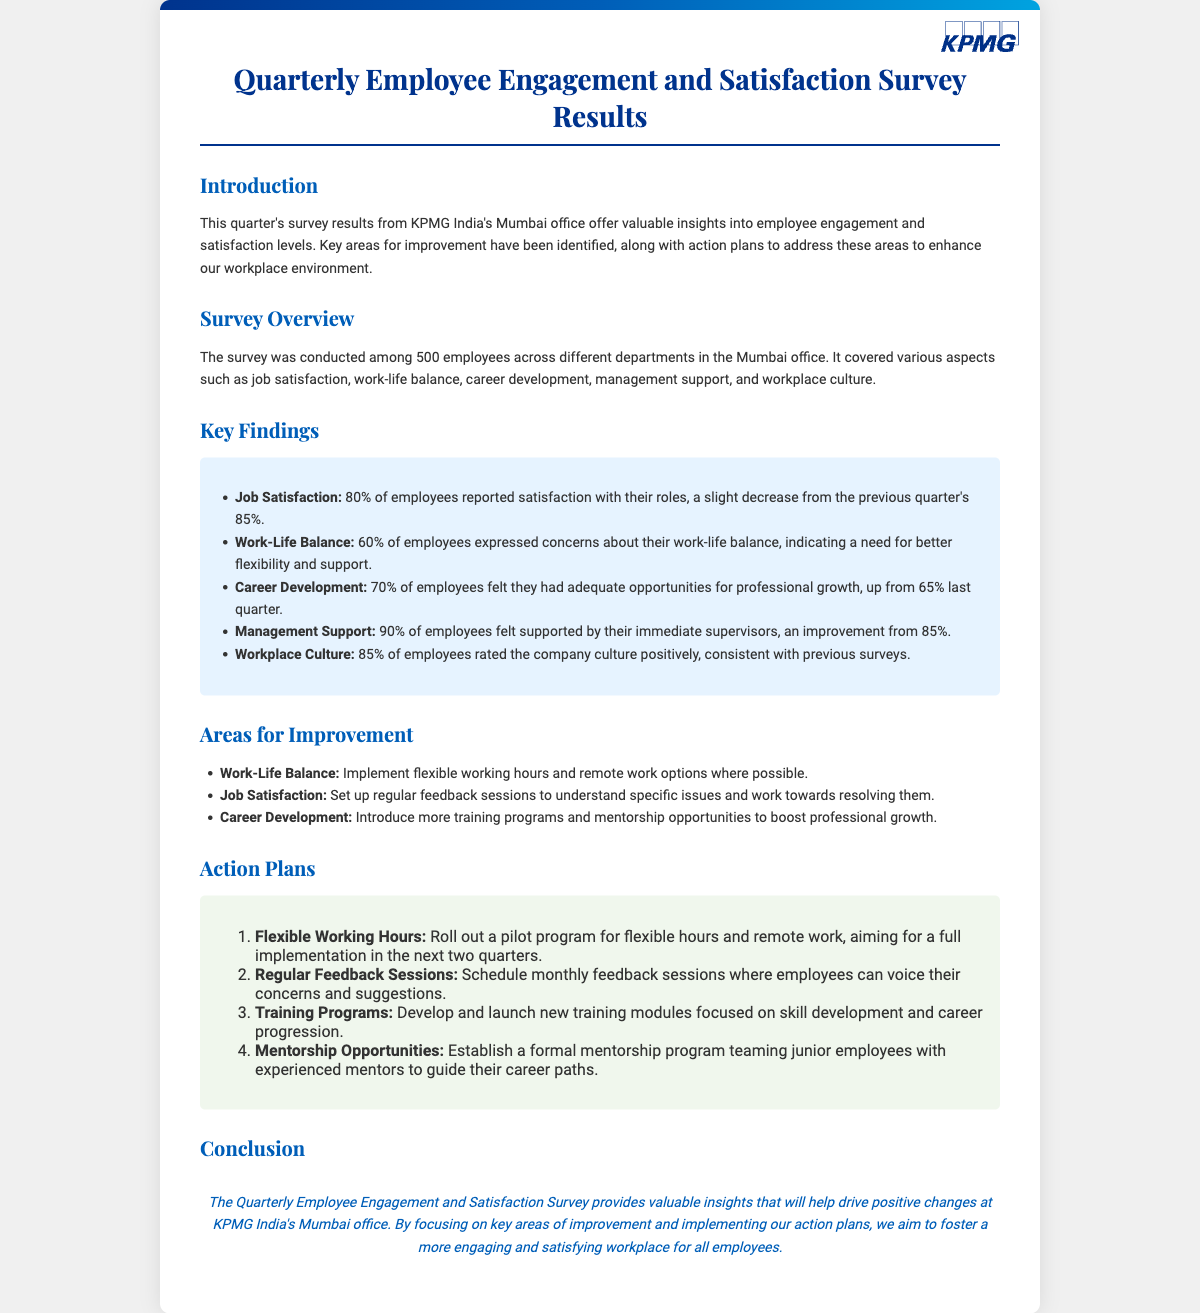what was the percentage of employees satisfied with their roles? 80% of employees reported satisfaction, down from 85% last quarter.
Answer: 80% what percentage of employees expressed concerns about work-life balance? 60% of employees expressed concerns, indicating a need for better flexibility.
Answer: 60% how many employees participated in the survey? The survey was conducted among 500 employees across different departments.
Answer: 500 what is one action plan related to flexible working? A pilot program for flexible hours and remote work is scheduled for implementation in the next two quarters.
Answer: Pilot program which area had the highest percentage rating for management support? 90% of employees felt supported by their immediate supervisors, an improvement from 85%.
Answer: 90% what was the increase in employees feeling they had career development opportunities? The percentage increased from 65% last quarter to 70% this quarter.
Answer: 5% what is one of the areas identified for improvement concerning job satisfaction? Conduct regular feedback sessions to understand specific issues.
Answer: Feedback sessions what is the conclusion statement about the survey's importance? The survey provides insights to drive positive changes in the workplace.
Answer: Insights for positive changes what did the survey measure in addition to employee satisfaction? It covered aspects like job satisfaction, work-life balance, career development, management support, and workplace culture.
Answer: Multiple aspects 